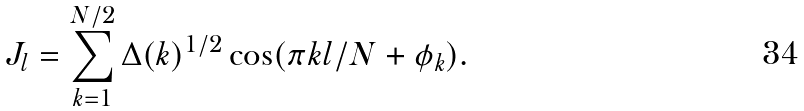<formula> <loc_0><loc_0><loc_500><loc_500>J _ { l } = \sum _ { k = 1 } ^ { N / 2 } \Delta ( k ) ^ { 1 / 2 } \cos ( \pi k l / N + \phi _ { k } ) .</formula> 